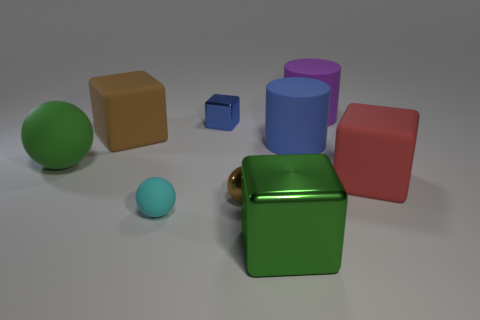Subtract all rubber spheres. How many spheres are left? 1 Subtract all purple cylinders. How many cylinders are left? 1 Subtract 1 blocks. How many blocks are left? 3 Subtract all green balls. How many purple cylinders are left? 1 Subtract all big matte objects. Subtract all big brown objects. How many objects are left? 3 Add 3 spheres. How many spheres are left? 6 Add 6 big red matte cylinders. How many big red matte cylinders exist? 6 Subtract 1 red cubes. How many objects are left? 8 Subtract all cylinders. How many objects are left? 7 Subtract all brown balls. Subtract all cyan cylinders. How many balls are left? 2 